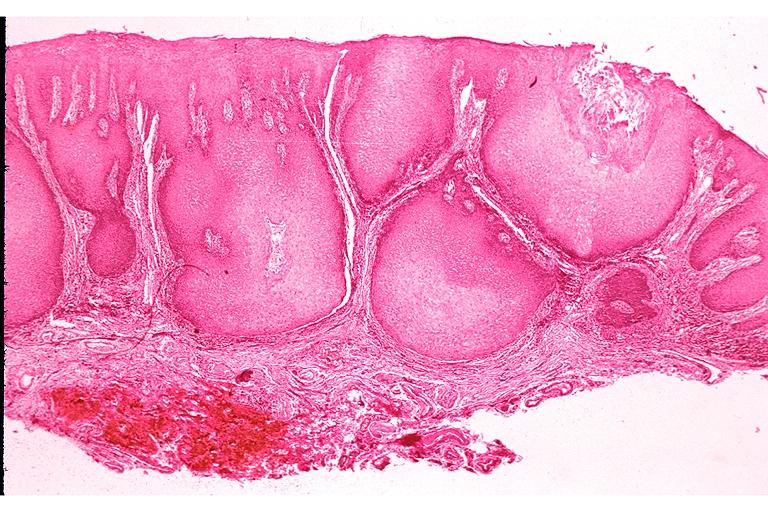s sella present?
Answer the question using a single word or phrase. No 